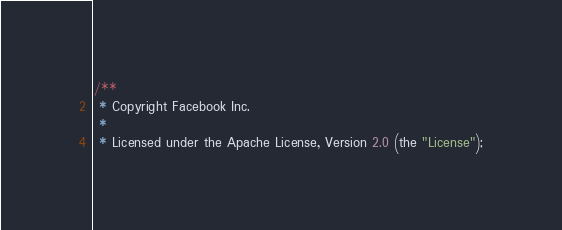<code> <loc_0><loc_0><loc_500><loc_500><_JavaScript_>/**
 * Copyright Facebook Inc.
 *
 * Licensed under the Apache License, Version 2.0 (the "License");</code> 